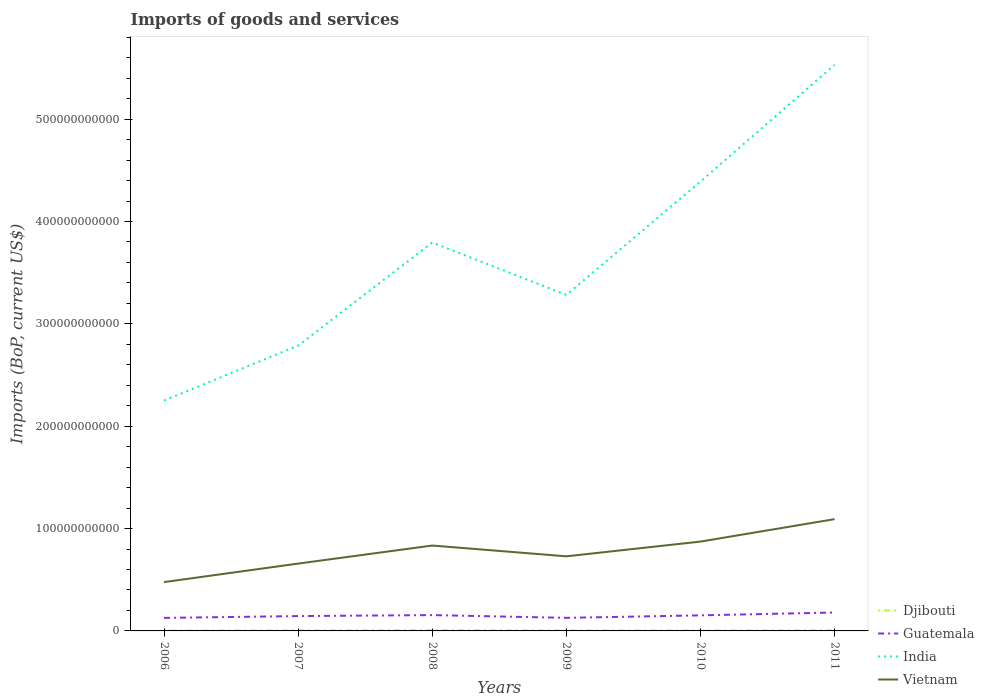How many different coloured lines are there?
Ensure brevity in your answer.  4. Is the number of lines equal to the number of legend labels?
Keep it short and to the point. Yes. Across all years, what is the maximum amount spent on imports in Djibouti?
Provide a succinct answer. 4.25e+08. In which year was the amount spent on imports in India maximum?
Make the answer very short. 2006. What is the total amount spent on imports in Djibouti in the graph?
Give a very brief answer. -1.80e+08. What is the difference between the highest and the second highest amount spent on imports in Guatemala?
Make the answer very short. 5.29e+09. Is the amount spent on imports in Djibouti strictly greater than the amount spent on imports in India over the years?
Offer a very short reply. Yes. How many lines are there?
Ensure brevity in your answer.  4. What is the difference between two consecutive major ticks on the Y-axis?
Offer a very short reply. 1.00e+11. Does the graph contain any zero values?
Offer a very short reply. No. Does the graph contain grids?
Provide a short and direct response. No. Where does the legend appear in the graph?
Keep it short and to the point. Bottom right. How are the legend labels stacked?
Keep it short and to the point. Vertical. What is the title of the graph?
Your response must be concise. Imports of goods and services. What is the label or title of the X-axis?
Ensure brevity in your answer.  Years. What is the label or title of the Y-axis?
Keep it short and to the point. Imports (BoP, current US$). What is the Imports (BoP, current US$) of Djibouti in 2006?
Keep it short and to the point. 4.25e+08. What is the Imports (BoP, current US$) in Guatemala in 2006?
Make the answer very short. 1.27e+1. What is the Imports (BoP, current US$) in India in 2006?
Make the answer very short. 2.25e+11. What is the Imports (BoP, current US$) in Vietnam in 2006?
Provide a short and direct response. 4.77e+1. What is the Imports (BoP, current US$) in Djibouti in 2007?
Keep it short and to the point. 5.69e+08. What is the Imports (BoP, current US$) in Guatemala in 2007?
Offer a very short reply. 1.45e+1. What is the Imports (BoP, current US$) of India in 2007?
Give a very brief answer. 2.79e+11. What is the Imports (BoP, current US$) of Vietnam in 2007?
Your answer should be compact. 6.58e+1. What is the Imports (BoP, current US$) in Djibouti in 2008?
Provide a succinct answer. 6.91e+08. What is the Imports (BoP, current US$) of Guatemala in 2008?
Offer a very short reply. 1.55e+1. What is the Imports (BoP, current US$) in India in 2008?
Offer a terse response. 3.79e+11. What is the Imports (BoP, current US$) in Vietnam in 2008?
Offer a very short reply. 8.34e+1. What is the Imports (BoP, current US$) of Djibouti in 2009?
Your answer should be very brief. 5.65e+08. What is the Imports (BoP, current US$) in Guatemala in 2009?
Your answer should be compact. 1.28e+1. What is the Imports (BoP, current US$) in India in 2009?
Your response must be concise. 3.28e+11. What is the Imports (BoP, current US$) in Vietnam in 2009?
Give a very brief answer. 7.29e+1. What is the Imports (BoP, current US$) in Djibouti in 2010?
Offer a very short reply. 4.78e+08. What is the Imports (BoP, current US$) of Guatemala in 2010?
Provide a short and direct response. 1.52e+1. What is the Imports (BoP, current US$) in India in 2010?
Offer a terse response. 4.39e+11. What is the Imports (BoP, current US$) of Vietnam in 2010?
Make the answer very short. 8.73e+1. What is the Imports (BoP, current US$) of Djibouti in 2011?
Your answer should be very brief. 6.58e+08. What is the Imports (BoP, current US$) in Guatemala in 2011?
Offer a terse response. 1.80e+1. What is the Imports (BoP, current US$) of India in 2011?
Your answer should be very brief. 5.53e+11. What is the Imports (BoP, current US$) of Vietnam in 2011?
Keep it short and to the point. 1.09e+11. Across all years, what is the maximum Imports (BoP, current US$) in Djibouti?
Give a very brief answer. 6.91e+08. Across all years, what is the maximum Imports (BoP, current US$) of Guatemala?
Your response must be concise. 1.80e+1. Across all years, what is the maximum Imports (BoP, current US$) of India?
Your answer should be very brief. 5.53e+11. Across all years, what is the maximum Imports (BoP, current US$) of Vietnam?
Keep it short and to the point. 1.09e+11. Across all years, what is the minimum Imports (BoP, current US$) in Djibouti?
Offer a very short reply. 4.25e+08. Across all years, what is the minimum Imports (BoP, current US$) in Guatemala?
Your answer should be very brief. 1.27e+1. Across all years, what is the minimum Imports (BoP, current US$) of India?
Give a very brief answer. 2.25e+11. Across all years, what is the minimum Imports (BoP, current US$) of Vietnam?
Your answer should be compact. 4.77e+1. What is the total Imports (BoP, current US$) in Djibouti in the graph?
Your answer should be very brief. 3.39e+09. What is the total Imports (BoP, current US$) of Guatemala in the graph?
Offer a terse response. 8.87e+1. What is the total Imports (BoP, current US$) in India in the graph?
Your answer should be compact. 2.20e+12. What is the total Imports (BoP, current US$) of Vietnam in the graph?
Provide a succinct answer. 4.66e+11. What is the difference between the Imports (BoP, current US$) of Djibouti in 2006 and that in 2007?
Provide a succinct answer. -1.44e+08. What is the difference between the Imports (BoP, current US$) of Guatemala in 2006 and that in 2007?
Make the answer very short. -1.80e+09. What is the difference between the Imports (BoP, current US$) in India in 2006 and that in 2007?
Your answer should be compact. -5.37e+1. What is the difference between the Imports (BoP, current US$) of Vietnam in 2006 and that in 2007?
Keep it short and to the point. -1.81e+1. What is the difference between the Imports (BoP, current US$) in Djibouti in 2006 and that in 2008?
Ensure brevity in your answer.  -2.66e+08. What is the difference between the Imports (BoP, current US$) in Guatemala in 2006 and that in 2008?
Give a very brief answer. -2.75e+09. What is the difference between the Imports (BoP, current US$) of India in 2006 and that in 2008?
Your answer should be very brief. -1.54e+11. What is the difference between the Imports (BoP, current US$) of Vietnam in 2006 and that in 2008?
Make the answer very short. -3.57e+1. What is the difference between the Imports (BoP, current US$) in Djibouti in 2006 and that in 2009?
Provide a succinct answer. -1.40e+08. What is the difference between the Imports (BoP, current US$) of Guatemala in 2006 and that in 2009?
Provide a succinct answer. -6.18e+07. What is the difference between the Imports (BoP, current US$) in India in 2006 and that in 2009?
Your response must be concise. -1.03e+11. What is the difference between the Imports (BoP, current US$) in Vietnam in 2006 and that in 2009?
Offer a terse response. -2.52e+1. What is the difference between the Imports (BoP, current US$) in Djibouti in 2006 and that in 2010?
Ensure brevity in your answer.  -5.34e+07. What is the difference between the Imports (BoP, current US$) in Guatemala in 2006 and that in 2010?
Provide a succinct answer. -2.50e+09. What is the difference between the Imports (BoP, current US$) of India in 2006 and that in 2010?
Offer a terse response. -2.14e+11. What is the difference between the Imports (BoP, current US$) in Vietnam in 2006 and that in 2010?
Keep it short and to the point. -3.96e+1. What is the difference between the Imports (BoP, current US$) in Djibouti in 2006 and that in 2011?
Make the answer very short. -2.33e+08. What is the difference between the Imports (BoP, current US$) in Guatemala in 2006 and that in 2011?
Ensure brevity in your answer.  -5.29e+09. What is the difference between the Imports (BoP, current US$) in India in 2006 and that in 2011?
Give a very brief answer. -3.28e+11. What is the difference between the Imports (BoP, current US$) of Vietnam in 2006 and that in 2011?
Ensure brevity in your answer.  -6.15e+1. What is the difference between the Imports (BoP, current US$) in Djibouti in 2007 and that in 2008?
Your response must be concise. -1.22e+08. What is the difference between the Imports (BoP, current US$) of Guatemala in 2007 and that in 2008?
Give a very brief answer. -9.53e+08. What is the difference between the Imports (BoP, current US$) in India in 2007 and that in 2008?
Provide a succinct answer. -1.01e+11. What is the difference between the Imports (BoP, current US$) in Vietnam in 2007 and that in 2008?
Ensure brevity in your answer.  -1.76e+1. What is the difference between the Imports (BoP, current US$) of Djibouti in 2007 and that in 2009?
Your answer should be very brief. 3.92e+06. What is the difference between the Imports (BoP, current US$) in Guatemala in 2007 and that in 2009?
Give a very brief answer. 1.74e+09. What is the difference between the Imports (BoP, current US$) in India in 2007 and that in 2009?
Give a very brief answer. -4.95e+1. What is the difference between the Imports (BoP, current US$) of Vietnam in 2007 and that in 2009?
Offer a very short reply. -7.11e+09. What is the difference between the Imports (BoP, current US$) in Djibouti in 2007 and that in 2010?
Offer a very short reply. 9.02e+07. What is the difference between the Imports (BoP, current US$) in Guatemala in 2007 and that in 2010?
Your answer should be compact. -7.02e+08. What is the difference between the Imports (BoP, current US$) of India in 2007 and that in 2010?
Make the answer very short. -1.60e+11. What is the difference between the Imports (BoP, current US$) of Vietnam in 2007 and that in 2010?
Provide a short and direct response. -2.15e+1. What is the difference between the Imports (BoP, current US$) of Djibouti in 2007 and that in 2011?
Your answer should be compact. -8.98e+07. What is the difference between the Imports (BoP, current US$) in Guatemala in 2007 and that in 2011?
Your answer should be very brief. -3.49e+09. What is the difference between the Imports (BoP, current US$) of India in 2007 and that in 2011?
Your response must be concise. -2.74e+11. What is the difference between the Imports (BoP, current US$) in Vietnam in 2007 and that in 2011?
Offer a terse response. -4.34e+1. What is the difference between the Imports (BoP, current US$) of Djibouti in 2008 and that in 2009?
Provide a short and direct response. 1.26e+08. What is the difference between the Imports (BoP, current US$) of Guatemala in 2008 and that in 2009?
Offer a terse response. 2.69e+09. What is the difference between the Imports (BoP, current US$) of India in 2008 and that in 2009?
Your answer should be compact. 5.12e+1. What is the difference between the Imports (BoP, current US$) in Vietnam in 2008 and that in 2009?
Your response must be concise. 1.05e+1. What is the difference between the Imports (BoP, current US$) of Djibouti in 2008 and that in 2010?
Your response must be concise. 2.12e+08. What is the difference between the Imports (BoP, current US$) of Guatemala in 2008 and that in 2010?
Your answer should be compact. 2.51e+08. What is the difference between the Imports (BoP, current US$) of India in 2008 and that in 2010?
Ensure brevity in your answer.  -5.96e+1. What is the difference between the Imports (BoP, current US$) of Vietnam in 2008 and that in 2010?
Give a very brief answer. -3.87e+09. What is the difference between the Imports (BoP, current US$) in Djibouti in 2008 and that in 2011?
Ensure brevity in your answer.  3.23e+07. What is the difference between the Imports (BoP, current US$) in Guatemala in 2008 and that in 2011?
Your response must be concise. -2.53e+09. What is the difference between the Imports (BoP, current US$) of India in 2008 and that in 2011?
Provide a succinct answer. -1.74e+11. What is the difference between the Imports (BoP, current US$) of Vietnam in 2008 and that in 2011?
Give a very brief answer. -2.58e+1. What is the difference between the Imports (BoP, current US$) of Djibouti in 2009 and that in 2010?
Your response must be concise. 8.62e+07. What is the difference between the Imports (BoP, current US$) of Guatemala in 2009 and that in 2010?
Offer a terse response. -2.44e+09. What is the difference between the Imports (BoP, current US$) in India in 2009 and that in 2010?
Give a very brief answer. -1.11e+11. What is the difference between the Imports (BoP, current US$) of Vietnam in 2009 and that in 2010?
Offer a very short reply. -1.44e+1. What is the difference between the Imports (BoP, current US$) in Djibouti in 2009 and that in 2011?
Your response must be concise. -9.37e+07. What is the difference between the Imports (BoP, current US$) in Guatemala in 2009 and that in 2011?
Your answer should be compact. -5.22e+09. What is the difference between the Imports (BoP, current US$) in India in 2009 and that in 2011?
Give a very brief answer. -2.25e+11. What is the difference between the Imports (BoP, current US$) of Vietnam in 2009 and that in 2011?
Your answer should be very brief. -3.63e+1. What is the difference between the Imports (BoP, current US$) in Djibouti in 2010 and that in 2011?
Provide a short and direct response. -1.80e+08. What is the difference between the Imports (BoP, current US$) of Guatemala in 2010 and that in 2011?
Offer a terse response. -2.79e+09. What is the difference between the Imports (BoP, current US$) of India in 2010 and that in 2011?
Make the answer very short. -1.14e+11. What is the difference between the Imports (BoP, current US$) in Vietnam in 2010 and that in 2011?
Offer a very short reply. -2.19e+1. What is the difference between the Imports (BoP, current US$) in Djibouti in 2006 and the Imports (BoP, current US$) in Guatemala in 2007?
Provide a succinct answer. -1.41e+1. What is the difference between the Imports (BoP, current US$) in Djibouti in 2006 and the Imports (BoP, current US$) in India in 2007?
Give a very brief answer. -2.78e+11. What is the difference between the Imports (BoP, current US$) of Djibouti in 2006 and the Imports (BoP, current US$) of Vietnam in 2007?
Ensure brevity in your answer.  -6.54e+1. What is the difference between the Imports (BoP, current US$) of Guatemala in 2006 and the Imports (BoP, current US$) of India in 2007?
Your answer should be very brief. -2.66e+11. What is the difference between the Imports (BoP, current US$) in Guatemala in 2006 and the Imports (BoP, current US$) in Vietnam in 2007?
Provide a succinct answer. -5.31e+1. What is the difference between the Imports (BoP, current US$) in India in 2006 and the Imports (BoP, current US$) in Vietnam in 2007?
Give a very brief answer. 1.59e+11. What is the difference between the Imports (BoP, current US$) of Djibouti in 2006 and the Imports (BoP, current US$) of Guatemala in 2008?
Give a very brief answer. -1.50e+1. What is the difference between the Imports (BoP, current US$) of Djibouti in 2006 and the Imports (BoP, current US$) of India in 2008?
Offer a very short reply. -3.79e+11. What is the difference between the Imports (BoP, current US$) in Djibouti in 2006 and the Imports (BoP, current US$) in Vietnam in 2008?
Your answer should be very brief. -8.30e+1. What is the difference between the Imports (BoP, current US$) of Guatemala in 2006 and the Imports (BoP, current US$) of India in 2008?
Offer a very short reply. -3.67e+11. What is the difference between the Imports (BoP, current US$) in Guatemala in 2006 and the Imports (BoP, current US$) in Vietnam in 2008?
Offer a terse response. -7.07e+1. What is the difference between the Imports (BoP, current US$) in India in 2006 and the Imports (BoP, current US$) in Vietnam in 2008?
Your answer should be compact. 1.42e+11. What is the difference between the Imports (BoP, current US$) of Djibouti in 2006 and the Imports (BoP, current US$) of Guatemala in 2009?
Your answer should be very brief. -1.23e+1. What is the difference between the Imports (BoP, current US$) of Djibouti in 2006 and the Imports (BoP, current US$) of India in 2009?
Your answer should be compact. -3.28e+11. What is the difference between the Imports (BoP, current US$) of Djibouti in 2006 and the Imports (BoP, current US$) of Vietnam in 2009?
Make the answer very short. -7.25e+1. What is the difference between the Imports (BoP, current US$) of Guatemala in 2006 and the Imports (BoP, current US$) of India in 2009?
Ensure brevity in your answer.  -3.16e+11. What is the difference between the Imports (BoP, current US$) in Guatemala in 2006 and the Imports (BoP, current US$) in Vietnam in 2009?
Give a very brief answer. -6.02e+1. What is the difference between the Imports (BoP, current US$) in India in 2006 and the Imports (BoP, current US$) in Vietnam in 2009?
Offer a very short reply. 1.52e+11. What is the difference between the Imports (BoP, current US$) in Djibouti in 2006 and the Imports (BoP, current US$) in Guatemala in 2010?
Offer a very short reply. -1.48e+1. What is the difference between the Imports (BoP, current US$) in Djibouti in 2006 and the Imports (BoP, current US$) in India in 2010?
Keep it short and to the point. -4.39e+11. What is the difference between the Imports (BoP, current US$) of Djibouti in 2006 and the Imports (BoP, current US$) of Vietnam in 2010?
Your response must be concise. -8.69e+1. What is the difference between the Imports (BoP, current US$) in Guatemala in 2006 and the Imports (BoP, current US$) in India in 2010?
Your response must be concise. -4.26e+11. What is the difference between the Imports (BoP, current US$) in Guatemala in 2006 and the Imports (BoP, current US$) in Vietnam in 2010?
Make the answer very short. -7.46e+1. What is the difference between the Imports (BoP, current US$) in India in 2006 and the Imports (BoP, current US$) in Vietnam in 2010?
Ensure brevity in your answer.  1.38e+11. What is the difference between the Imports (BoP, current US$) in Djibouti in 2006 and the Imports (BoP, current US$) in Guatemala in 2011?
Offer a very short reply. -1.76e+1. What is the difference between the Imports (BoP, current US$) of Djibouti in 2006 and the Imports (BoP, current US$) of India in 2011?
Your answer should be compact. -5.53e+11. What is the difference between the Imports (BoP, current US$) of Djibouti in 2006 and the Imports (BoP, current US$) of Vietnam in 2011?
Provide a succinct answer. -1.09e+11. What is the difference between the Imports (BoP, current US$) in Guatemala in 2006 and the Imports (BoP, current US$) in India in 2011?
Make the answer very short. -5.40e+11. What is the difference between the Imports (BoP, current US$) of Guatemala in 2006 and the Imports (BoP, current US$) of Vietnam in 2011?
Keep it short and to the point. -9.65e+1. What is the difference between the Imports (BoP, current US$) of India in 2006 and the Imports (BoP, current US$) of Vietnam in 2011?
Make the answer very short. 1.16e+11. What is the difference between the Imports (BoP, current US$) of Djibouti in 2007 and the Imports (BoP, current US$) of Guatemala in 2008?
Make the answer very short. -1.49e+1. What is the difference between the Imports (BoP, current US$) in Djibouti in 2007 and the Imports (BoP, current US$) in India in 2008?
Provide a short and direct response. -3.79e+11. What is the difference between the Imports (BoP, current US$) in Djibouti in 2007 and the Imports (BoP, current US$) in Vietnam in 2008?
Your answer should be compact. -8.29e+1. What is the difference between the Imports (BoP, current US$) of Guatemala in 2007 and the Imports (BoP, current US$) of India in 2008?
Ensure brevity in your answer.  -3.65e+11. What is the difference between the Imports (BoP, current US$) of Guatemala in 2007 and the Imports (BoP, current US$) of Vietnam in 2008?
Ensure brevity in your answer.  -6.89e+1. What is the difference between the Imports (BoP, current US$) in India in 2007 and the Imports (BoP, current US$) in Vietnam in 2008?
Offer a very short reply. 1.95e+11. What is the difference between the Imports (BoP, current US$) of Djibouti in 2007 and the Imports (BoP, current US$) of Guatemala in 2009?
Provide a short and direct response. -1.22e+1. What is the difference between the Imports (BoP, current US$) in Djibouti in 2007 and the Imports (BoP, current US$) in India in 2009?
Provide a short and direct response. -3.28e+11. What is the difference between the Imports (BoP, current US$) in Djibouti in 2007 and the Imports (BoP, current US$) in Vietnam in 2009?
Offer a terse response. -7.23e+1. What is the difference between the Imports (BoP, current US$) of Guatemala in 2007 and the Imports (BoP, current US$) of India in 2009?
Your response must be concise. -3.14e+11. What is the difference between the Imports (BoP, current US$) of Guatemala in 2007 and the Imports (BoP, current US$) of Vietnam in 2009?
Ensure brevity in your answer.  -5.84e+1. What is the difference between the Imports (BoP, current US$) in India in 2007 and the Imports (BoP, current US$) in Vietnam in 2009?
Ensure brevity in your answer.  2.06e+11. What is the difference between the Imports (BoP, current US$) in Djibouti in 2007 and the Imports (BoP, current US$) in Guatemala in 2010?
Provide a short and direct response. -1.46e+1. What is the difference between the Imports (BoP, current US$) of Djibouti in 2007 and the Imports (BoP, current US$) of India in 2010?
Provide a succinct answer. -4.38e+11. What is the difference between the Imports (BoP, current US$) of Djibouti in 2007 and the Imports (BoP, current US$) of Vietnam in 2010?
Your response must be concise. -8.67e+1. What is the difference between the Imports (BoP, current US$) in Guatemala in 2007 and the Imports (BoP, current US$) in India in 2010?
Make the answer very short. -4.25e+11. What is the difference between the Imports (BoP, current US$) of Guatemala in 2007 and the Imports (BoP, current US$) of Vietnam in 2010?
Your answer should be very brief. -7.28e+1. What is the difference between the Imports (BoP, current US$) in India in 2007 and the Imports (BoP, current US$) in Vietnam in 2010?
Your answer should be compact. 1.91e+11. What is the difference between the Imports (BoP, current US$) of Djibouti in 2007 and the Imports (BoP, current US$) of Guatemala in 2011?
Make the answer very short. -1.74e+1. What is the difference between the Imports (BoP, current US$) of Djibouti in 2007 and the Imports (BoP, current US$) of India in 2011?
Provide a succinct answer. -5.52e+11. What is the difference between the Imports (BoP, current US$) in Djibouti in 2007 and the Imports (BoP, current US$) in Vietnam in 2011?
Your answer should be very brief. -1.09e+11. What is the difference between the Imports (BoP, current US$) of Guatemala in 2007 and the Imports (BoP, current US$) of India in 2011?
Offer a very short reply. -5.39e+11. What is the difference between the Imports (BoP, current US$) in Guatemala in 2007 and the Imports (BoP, current US$) in Vietnam in 2011?
Make the answer very short. -9.47e+1. What is the difference between the Imports (BoP, current US$) of India in 2007 and the Imports (BoP, current US$) of Vietnam in 2011?
Your answer should be compact. 1.70e+11. What is the difference between the Imports (BoP, current US$) in Djibouti in 2008 and the Imports (BoP, current US$) in Guatemala in 2009?
Make the answer very short. -1.21e+1. What is the difference between the Imports (BoP, current US$) in Djibouti in 2008 and the Imports (BoP, current US$) in India in 2009?
Provide a short and direct response. -3.28e+11. What is the difference between the Imports (BoP, current US$) of Djibouti in 2008 and the Imports (BoP, current US$) of Vietnam in 2009?
Ensure brevity in your answer.  -7.22e+1. What is the difference between the Imports (BoP, current US$) of Guatemala in 2008 and the Imports (BoP, current US$) of India in 2009?
Make the answer very short. -3.13e+11. What is the difference between the Imports (BoP, current US$) in Guatemala in 2008 and the Imports (BoP, current US$) in Vietnam in 2009?
Ensure brevity in your answer.  -5.74e+1. What is the difference between the Imports (BoP, current US$) in India in 2008 and the Imports (BoP, current US$) in Vietnam in 2009?
Provide a succinct answer. 3.07e+11. What is the difference between the Imports (BoP, current US$) in Djibouti in 2008 and the Imports (BoP, current US$) in Guatemala in 2010?
Give a very brief answer. -1.45e+1. What is the difference between the Imports (BoP, current US$) in Djibouti in 2008 and the Imports (BoP, current US$) in India in 2010?
Your response must be concise. -4.38e+11. What is the difference between the Imports (BoP, current US$) of Djibouti in 2008 and the Imports (BoP, current US$) of Vietnam in 2010?
Your answer should be compact. -8.66e+1. What is the difference between the Imports (BoP, current US$) in Guatemala in 2008 and the Imports (BoP, current US$) in India in 2010?
Provide a succinct answer. -4.24e+11. What is the difference between the Imports (BoP, current US$) in Guatemala in 2008 and the Imports (BoP, current US$) in Vietnam in 2010?
Offer a terse response. -7.18e+1. What is the difference between the Imports (BoP, current US$) in India in 2008 and the Imports (BoP, current US$) in Vietnam in 2010?
Offer a very short reply. 2.92e+11. What is the difference between the Imports (BoP, current US$) in Djibouti in 2008 and the Imports (BoP, current US$) in Guatemala in 2011?
Your response must be concise. -1.73e+1. What is the difference between the Imports (BoP, current US$) in Djibouti in 2008 and the Imports (BoP, current US$) in India in 2011?
Make the answer very short. -5.52e+11. What is the difference between the Imports (BoP, current US$) of Djibouti in 2008 and the Imports (BoP, current US$) of Vietnam in 2011?
Offer a terse response. -1.09e+11. What is the difference between the Imports (BoP, current US$) of Guatemala in 2008 and the Imports (BoP, current US$) of India in 2011?
Offer a very short reply. -5.38e+11. What is the difference between the Imports (BoP, current US$) in Guatemala in 2008 and the Imports (BoP, current US$) in Vietnam in 2011?
Ensure brevity in your answer.  -9.38e+1. What is the difference between the Imports (BoP, current US$) of India in 2008 and the Imports (BoP, current US$) of Vietnam in 2011?
Provide a succinct answer. 2.70e+11. What is the difference between the Imports (BoP, current US$) of Djibouti in 2009 and the Imports (BoP, current US$) of Guatemala in 2010?
Give a very brief answer. -1.46e+1. What is the difference between the Imports (BoP, current US$) of Djibouti in 2009 and the Imports (BoP, current US$) of India in 2010?
Offer a terse response. -4.38e+11. What is the difference between the Imports (BoP, current US$) in Djibouti in 2009 and the Imports (BoP, current US$) in Vietnam in 2010?
Your answer should be very brief. -8.67e+1. What is the difference between the Imports (BoP, current US$) of Guatemala in 2009 and the Imports (BoP, current US$) of India in 2010?
Keep it short and to the point. -4.26e+11. What is the difference between the Imports (BoP, current US$) of Guatemala in 2009 and the Imports (BoP, current US$) of Vietnam in 2010?
Make the answer very short. -7.45e+1. What is the difference between the Imports (BoP, current US$) in India in 2009 and the Imports (BoP, current US$) in Vietnam in 2010?
Ensure brevity in your answer.  2.41e+11. What is the difference between the Imports (BoP, current US$) in Djibouti in 2009 and the Imports (BoP, current US$) in Guatemala in 2011?
Your answer should be compact. -1.74e+1. What is the difference between the Imports (BoP, current US$) in Djibouti in 2009 and the Imports (BoP, current US$) in India in 2011?
Offer a terse response. -5.52e+11. What is the difference between the Imports (BoP, current US$) of Djibouti in 2009 and the Imports (BoP, current US$) of Vietnam in 2011?
Your answer should be very brief. -1.09e+11. What is the difference between the Imports (BoP, current US$) in Guatemala in 2009 and the Imports (BoP, current US$) in India in 2011?
Your answer should be very brief. -5.40e+11. What is the difference between the Imports (BoP, current US$) of Guatemala in 2009 and the Imports (BoP, current US$) of Vietnam in 2011?
Your answer should be compact. -9.64e+1. What is the difference between the Imports (BoP, current US$) in India in 2009 and the Imports (BoP, current US$) in Vietnam in 2011?
Your response must be concise. 2.19e+11. What is the difference between the Imports (BoP, current US$) of Djibouti in 2010 and the Imports (BoP, current US$) of Guatemala in 2011?
Your answer should be very brief. -1.75e+1. What is the difference between the Imports (BoP, current US$) in Djibouti in 2010 and the Imports (BoP, current US$) in India in 2011?
Offer a terse response. -5.53e+11. What is the difference between the Imports (BoP, current US$) of Djibouti in 2010 and the Imports (BoP, current US$) of Vietnam in 2011?
Your response must be concise. -1.09e+11. What is the difference between the Imports (BoP, current US$) in Guatemala in 2010 and the Imports (BoP, current US$) in India in 2011?
Make the answer very short. -5.38e+11. What is the difference between the Imports (BoP, current US$) of Guatemala in 2010 and the Imports (BoP, current US$) of Vietnam in 2011?
Ensure brevity in your answer.  -9.40e+1. What is the difference between the Imports (BoP, current US$) in India in 2010 and the Imports (BoP, current US$) in Vietnam in 2011?
Keep it short and to the point. 3.30e+11. What is the average Imports (BoP, current US$) of Djibouti per year?
Give a very brief answer. 5.64e+08. What is the average Imports (BoP, current US$) of Guatemala per year?
Make the answer very short. 1.48e+1. What is the average Imports (BoP, current US$) of India per year?
Keep it short and to the point. 3.67e+11. What is the average Imports (BoP, current US$) in Vietnam per year?
Offer a very short reply. 7.77e+1. In the year 2006, what is the difference between the Imports (BoP, current US$) in Djibouti and Imports (BoP, current US$) in Guatemala?
Give a very brief answer. -1.23e+1. In the year 2006, what is the difference between the Imports (BoP, current US$) of Djibouti and Imports (BoP, current US$) of India?
Your answer should be compact. -2.25e+11. In the year 2006, what is the difference between the Imports (BoP, current US$) of Djibouti and Imports (BoP, current US$) of Vietnam?
Keep it short and to the point. -4.73e+1. In the year 2006, what is the difference between the Imports (BoP, current US$) in Guatemala and Imports (BoP, current US$) in India?
Keep it short and to the point. -2.12e+11. In the year 2006, what is the difference between the Imports (BoP, current US$) of Guatemala and Imports (BoP, current US$) of Vietnam?
Provide a succinct answer. -3.50e+1. In the year 2006, what is the difference between the Imports (BoP, current US$) of India and Imports (BoP, current US$) of Vietnam?
Your response must be concise. 1.77e+11. In the year 2007, what is the difference between the Imports (BoP, current US$) in Djibouti and Imports (BoP, current US$) in Guatemala?
Give a very brief answer. -1.39e+1. In the year 2007, what is the difference between the Imports (BoP, current US$) of Djibouti and Imports (BoP, current US$) of India?
Ensure brevity in your answer.  -2.78e+11. In the year 2007, what is the difference between the Imports (BoP, current US$) of Djibouti and Imports (BoP, current US$) of Vietnam?
Your answer should be compact. -6.52e+1. In the year 2007, what is the difference between the Imports (BoP, current US$) of Guatemala and Imports (BoP, current US$) of India?
Your answer should be very brief. -2.64e+11. In the year 2007, what is the difference between the Imports (BoP, current US$) in Guatemala and Imports (BoP, current US$) in Vietnam?
Offer a terse response. -5.13e+1. In the year 2007, what is the difference between the Imports (BoP, current US$) of India and Imports (BoP, current US$) of Vietnam?
Provide a short and direct response. 2.13e+11. In the year 2008, what is the difference between the Imports (BoP, current US$) in Djibouti and Imports (BoP, current US$) in Guatemala?
Give a very brief answer. -1.48e+1. In the year 2008, what is the difference between the Imports (BoP, current US$) of Djibouti and Imports (BoP, current US$) of India?
Your answer should be very brief. -3.79e+11. In the year 2008, what is the difference between the Imports (BoP, current US$) in Djibouti and Imports (BoP, current US$) in Vietnam?
Provide a succinct answer. -8.27e+1. In the year 2008, what is the difference between the Imports (BoP, current US$) of Guatemala and Imports (BoP, current US$) of India?
Your answer should be compact. -3.64e+11. In the year 2008, what is the difference between the Imports (BoP, current US$) in Guatemala and Imports (BoP, current US$) in Vietnam?
Provide a succinct answer. -6.80e+1. In the year 2008, what is the difference between the Imports (BoP, current US$) in India and Imports (BoP, current US$) in Vietnam?
Give a very brief answer. 2.96e+11. In the year 2009, what is the difference between the Imports (BoP, current US$) of Djibouti and Imports (BoP, current US$) of Guatemala?
Provide a succinct answer. -1.22e+1. In the year 2009, what is the difference between the Imports (BoP, current US$) of Djibouti and Imports (BoP, current US$) of India?
Offer a terse response. -3.28e+11. In the year 2009, what is the difference between the Imports (BoP, current US$) in Djibouti and Imports (BoP, current US$) in Vietnam?
Your answer should be compact. -7.23e+1. In the year 2009, what is the difference between the Imports (BoP, current US$) of Guatemala and Imports (BoP, current US$) of India?
Provide a succinct answer. -3.15e+11. In the year 2009, what is the difference between the Imports (BoP, current US$) in Guatemala and Imports (BoP, current US$) in Vietnam?
Your answer should be compact. -6.01e+1. In the year 2009, what is the difference between the Imports (BoP, current US$) in India and Imports (BoP, current US$) in Vietnam?
Your answer should be compact. 2.55e+11. In the year 2010, what is the difference between the Imports (BoP, current US$) of Djibouti and Imports (BoP, current US$) of Guatemala?
Your answer should be very brief. -1.47e+1. In the year 2010, what is the difference between the Imports (BoP, current US$) of Djibouti and Imports (BoP, current US$) of India?
Give a very brief answer. -4.39e+11. In the year 2010, what is the difference between the Imports (BoP, current US$) of Djibouti and Imports (BoP, current US$) of Vietnam?
Ensure brevity in your answer.  -8.68e+1. In the year 2010, what is the difference between the Imports (BoP, current US$) of Guatemala and Imports (BoP, current US$) of India?
Offer a terse response. -4.24e+11. In the year 2010, what is the difference between the Imports (BoP, current US$) in Guatemala and Imports (BoP, current US$) in Vietnam?
Keep it short and to the point. -7.21e+1. In the year 2010, what is the difference between the Imports (BoP, current US$) of India and Imports (BoP, current US$) of Vietnam?
Ensure brevity in your answer.  3.52e+11. In the year 2011, what is the difference between the Imports (BoP, current US$) of Djibouti and Imports (BoP, current US$) of Guatemala?
Your response must be concise. -1.73e+1. In the year 2011, what is the difference between the Imports (BoP, current US$) in Djibouti and Imports (BoP, current US$) in India?
Your response must be concise. -5.52e+11. In the year 2011, what is the difference between the Imports (BoP, current US$) of Djibouti and Imports (BoP, current US$) of Vietnam?
Your answer should be very brief. -1.09e+11. In the year 2011, what is the difference between the Imports (BoP, current US$) in Guatemala and Imports (BoP, current US$) in India?
Offer a very short reply. -5.35e+11. In the year 2011, what is the difference between the Imports (BoP, current US$) in Guatemala and Imports (BoP, current US$) in Vietnam?
Offer a very short reply. -9.12e+1. In the year 2011, what is the difference between the Imports (BoP, current US$) of India and Imports (BoP, current US$) of Vietnam?
Keep it short and to the point. 4.44e+11. What is the ratio of the Imports (BoP, current US$) in Djibouti in 2006 to that in 2007?
Your answer should be compact. 0.75. What is the ratio of the Imports (BoP, current US$) of Guatemala in 2006 to that in 2007?
Offer a very short reply. 0.88. What is the ratio of the Imports (BoP, current US$) in India in 2006 to that in 2007?
Your answer should be very brief. 0.81. What is the ratio of the Imports (BoP, current US$) in Vietnam in 2006 to that in 2007?
Offer a very short reply. 0.73. What is the ratio of the Imports (BoP, current US$) of Djibouti in 2006 to that in 2008?
Provide a succinct answer. 0.62. What is the ratio of the Imports (BoP, current US$) of Guatemala in 2006 to that in 2008?
Your response must be concise. 0.82. What is the ratio of the Imports (BoP, current US$) of India in 2006 to that in 2008?
Offer a very short reply. 0.59. What is the ratio of the Imports (BoP, current US$) in Vietnam in 2006 to that in 2008?
Your answer should be very brief. 0.57. What is the ratio of the Imports (BoP, current US$) of Djibouti in 2006 to that in 2009?
Offer a very short reply. 0.75. What is the ratio of the Imports (BoP, current US$) in India in 2006 to that in 2009?
Offer a very short reply. 0.69. What is the ratio of the Imports (BoP, current US$) of Vietnam in 2006 to that in 2009?
Offer a terse response. 0.65. What is the ratio of the Imports (BoP, current US$) of Djibouti in 2006 to that in 2010?
Ensure brevity in your answer.  0.89. What is the ratio of the Imports (BoP, current US$) of Guatemala in 2006 to that in 2010?
Keep it short and to the point. 0.84. What is the ratio of the Imports (BoP, current US$) in India in 2006 to that in 2010?
Your answer should be very brief. 0.51. What is the ratio of the Imports (BoP, current US$) in Vietnam in 2006 to that in 2010?
Ensure brevity in your answer.  0.55. What is the ratio of the Imports (BoP, current US$) in Djibouti in 2006 to that in 2011?
Your response must be concise. 0.65. What is the ratio of the Imports (BoP, current US$) of Guatemala in 2006 to that in 2011?
Make the answer very short. 0.71. What is the ratio of the Imports (BoP, current US$) in India in 2006 to that in 2011?
Provide a short and direct response. 0.41. What is the ratio of the Imports (BoP, current US$) in Vietnam in 2006 to that in 2011?
Your answer should be compact. 0.44. What is the ratio of the Imports (BoP, current US$) in Djibouti in 2007 to that in 2008?
Your answer should be compact. 0.82. What is the ratio of the Imports (BoP, current US$) in Guatemala in 2007 to that in 2008?
Ensure brevity in your answer.  0.94. What is the ratio of the Imports (BoP, current US$) in India in 2007 to that in 2008?
Offer a terse response. 0.73. What is the ratio of the Imports (BoP, current US$) of Vietnam in 2007 to that in 2008?
Make the answer very short. 0.79. What is the ratio of the Imports (BoP, current US$) of Guatemala in 2007 to that in 2009?
Offer a very short reply. 1.14. What is the ratio of the Imports (BoP, current US$) of India in 2007 to that in 2009?
Your response must be concise. 0.85. What is the ratio of the Imports (BoP, current US$) of Vietnam in 2007 to that in 2009?
Your response must be concise. 0.9. What is the ratio of the Imports (BoP, current US$) in Djibouti in 2007 to that in 2010?
Ensure brevity in your answer.  1.19. What is the ratio of the Imports (BoP, current US$) in Guatemala in 2007 to that in 2010?
Ensure brevity in your answer.  0.95. What is the ratio of the Imports (BoP, current US$) of India in 2007 to that in 2010?
Your response must be concise. 0.64. What is the ratio of the Imports (BoP, current US$) in Vietnam in 2007 to that in 2010?
Offer a very short reply. 0.75. What is the ratio of the Imports (BoP, current US$) in Djibouti in 2007 to that in 2011?
Offer a very short reply. 0.86. What is the ratio of the Imports (BoP, current US$) in Guatemala in 2007 to that in 2011?
Provide a short and direct response. 0.81. What is the ratio of the Imports (BoP, current US$) in India in 2007 to that in 2011?
Give a very brief answer. 0.5. What is the ratio of the Imports (BoP, current US$) of Vietnam in 2007 to that in 2011?
Your response must be concise. 0.6. What is the ratio of the Imports (BoP, current US$) of Djibouti in 2008 to that in 2009?
Make the answer very short. 1.22. What is the ratio of the Imports (BoP, current US$) in Guatemala in 2008 to that in 2009?
Your answer should be very brief. 1.21. What is the ratio of the Imports (BoP, current US$) of India in 2008 to that in 2009?
Make the answer very short. 1.16. What is the ratio of the Imports (BoP, current US$) in Vietnam in 2008 to that in 2009?
Keep it short and to the point. 1.14. What is the ratio of the Imports (BoP, current US$) of Djibouti in 2008 to that in 2010?
Provide a short and direct response. 1.44. What is the ratio of the Imports (BoP, current US$) in Guatemala in 2008 to that in 2010?
Your response must be concise. 1.02. What is the ratio of the Imports (BoP, current US$) of India in 2008 to that in 2010?
Make the answer very short. 0.86. What is the ratio of the Imports (BoP, current US$) in Vietnam in 2008 to that in 2010?
Offer a terse response. 0.96. What is the ratio of the Imports (BoP, current US$) in Djibouti in 2008 to that in 2011?
Make the answer very short. 1.05. What is the ratio of the Imports (BoP, current US$) in Guatemala in 2008 to that in 2011?
Offer a very short reply. 0.86. What is the ratio of the Imports (BoP, current US$) of India in 2008 to that in 2011?
Give a very brief answer. 0.69. What is the ratio of the Imports (BoP, current US$) in Vietnam in 2008 to that in 2011?
Your response must be concise. 0.76. What is the ratio of the Imports (BoP, current US$) in Djibouti in 2009 to that in 2010?
Your answer should be very brief. 1.18. What is the ratio of the Imports (BoP, current US$) in Guatemala in 2009 to that in 2010?
Offer a very short reply. 0.84. What is the ratio of the Imports (BoP, current US$) of India in 2009 to that in 2010?
Your answer should be very brief. 0.75. What is the ratio of the Imports (BoP, current US$) of Vietnam in 2009 to that in 2010?
Offer a very short reply. 0.83. What is the ratio of the Imports (BoP, current US$) of Djibouti in 2009 to that in 2011?
Your response must be concise. 0.86. What is the ratio of the Imports (BoP, current US$) of Guatemala in 2009 to that in 2011?
Give a very brief answer. 0.71. What is the ratio of the Imports (BoP, current US$) of India in 2009 to that in 2011?
Give a very brief answer. 0.59. What is the ratio of the Imports (BoP, current US$) in Vietnam in 2009 to that in 2011?
Offer a very short reply. 0.67. What is the ratio of the Imports (BoP, current US$) in Djibouti in 2010 to that in 2011?
Ensure brevity in your answer.  0.73. What is the ratio of the Imports (BoP, current US$) of Guatemala in 2010 to that in 2011?
Ensure brevity in your answer.  0.85. What is the ratio of the Imports (BoP, current US$) of India in 2010 to that in 2011?
Offer a terse response. 0.79. What is the ratio of the Imports (BoP, current US$) in Vietnam in 2010 to that in 2011?
Provide a short and direct response. 0.8. What is the difference between the highest and the second highest Imports (BoP, current US$) of Djibouti?
Offer a terse response. 3.23e+07. What is the difference between the highest and the second highest Imports (BoP, current US$) of Guatemala?
Provide a succinct answer. 2.53e+09. What is the difference between the highest and the second highest Imports (BoP, current US$) in India?
Your answer should be compact. 1.14e+11. What is the difference between the highest and the second highest Imports (BoP, current US$) of Vietnam?
Offer a very short reply. 2.19e+1. What is the difference between the highest and the lowest Imports (BoP, current US$) of Djibouti?
Ensure brevity in your answer.  2.66e+08. What is the difference between the highest and the lowest Imports (BoP, current US$) of Guatemala?
Make the answer very short. 5.29e+09. What is the difference between the highest and the lowest Imports (BoP, current US$) of India?
Make the answer very short. 3.28e+11. What is the difference between the highest and the lowest Imports (BoP, current US$) of Vietnam?
Your answer should be very brief. 6.15e+1. 